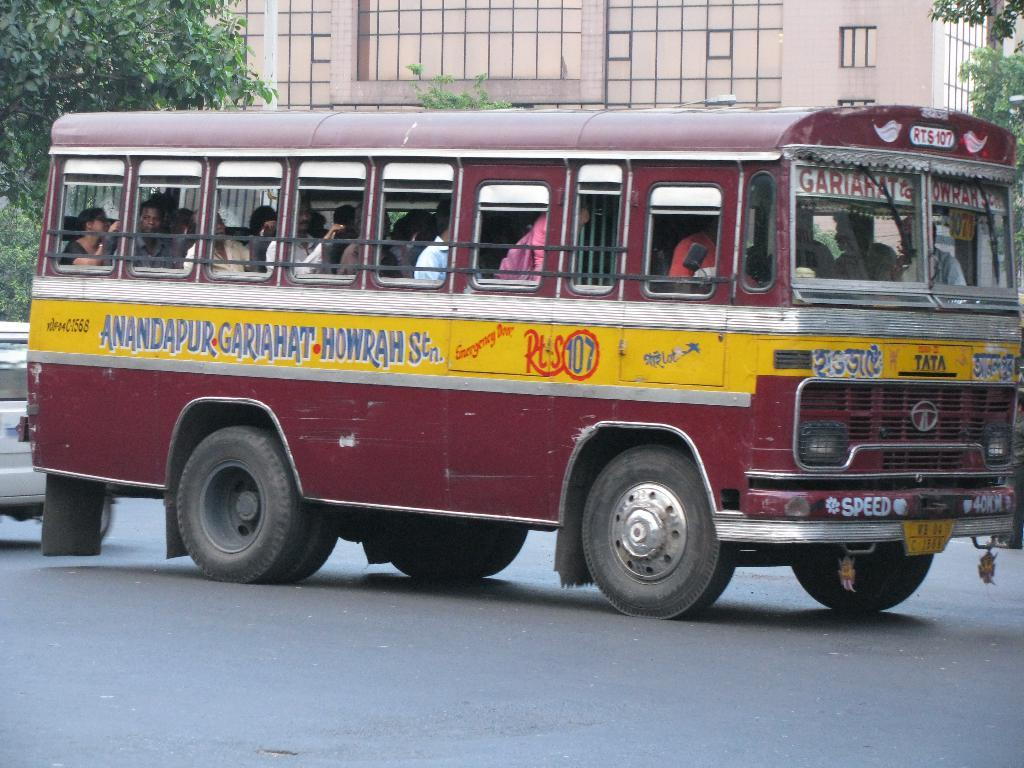<image>
Relay a brief, clear account of the picture shown. Maroon bus with a yellow strip with Anandapur Gariahat Howrah Stn. 